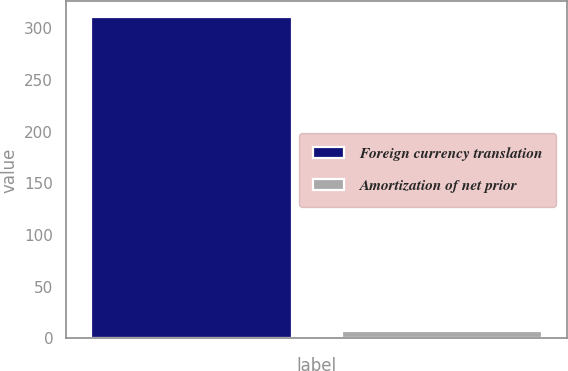Convert chart. <chart><loc_0><loc_0><loc_500><loc_500><bar_chart><fcel>Foreign currency translation<fcel>Amortization of net prior<nl><fcel>310.5<fcel>6.7<nl></chart> 